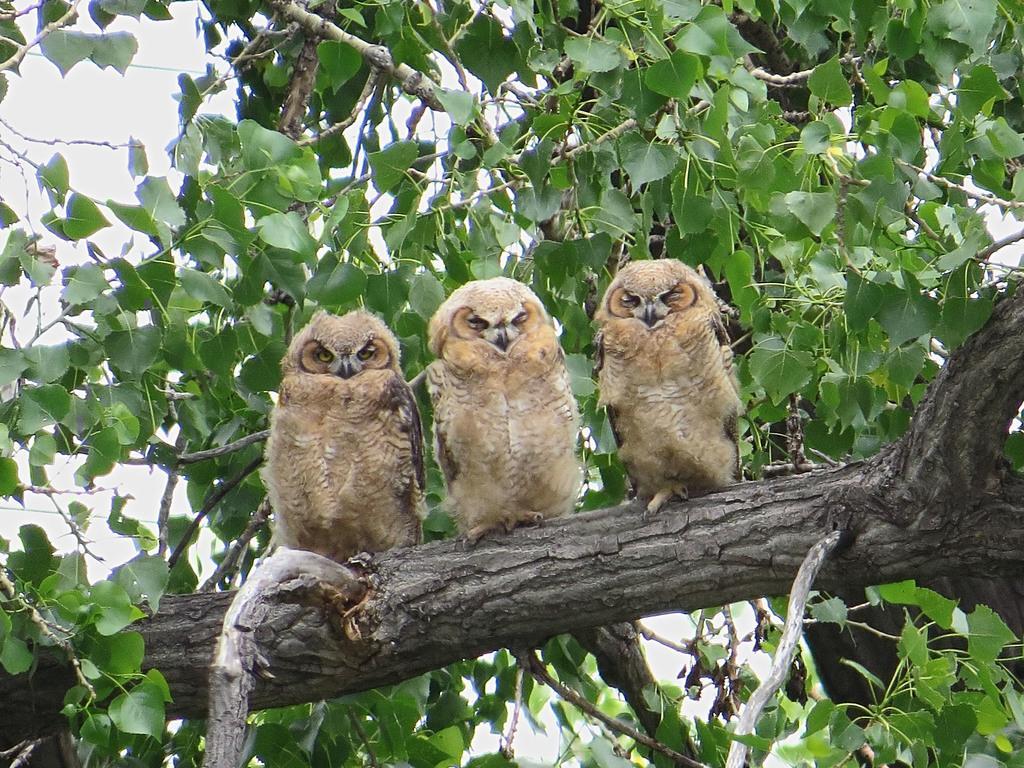Please provide a concise description of this image. In the center of the image we can see the owls are present on a branch. In the background of the image we can see the leaves and sky. 